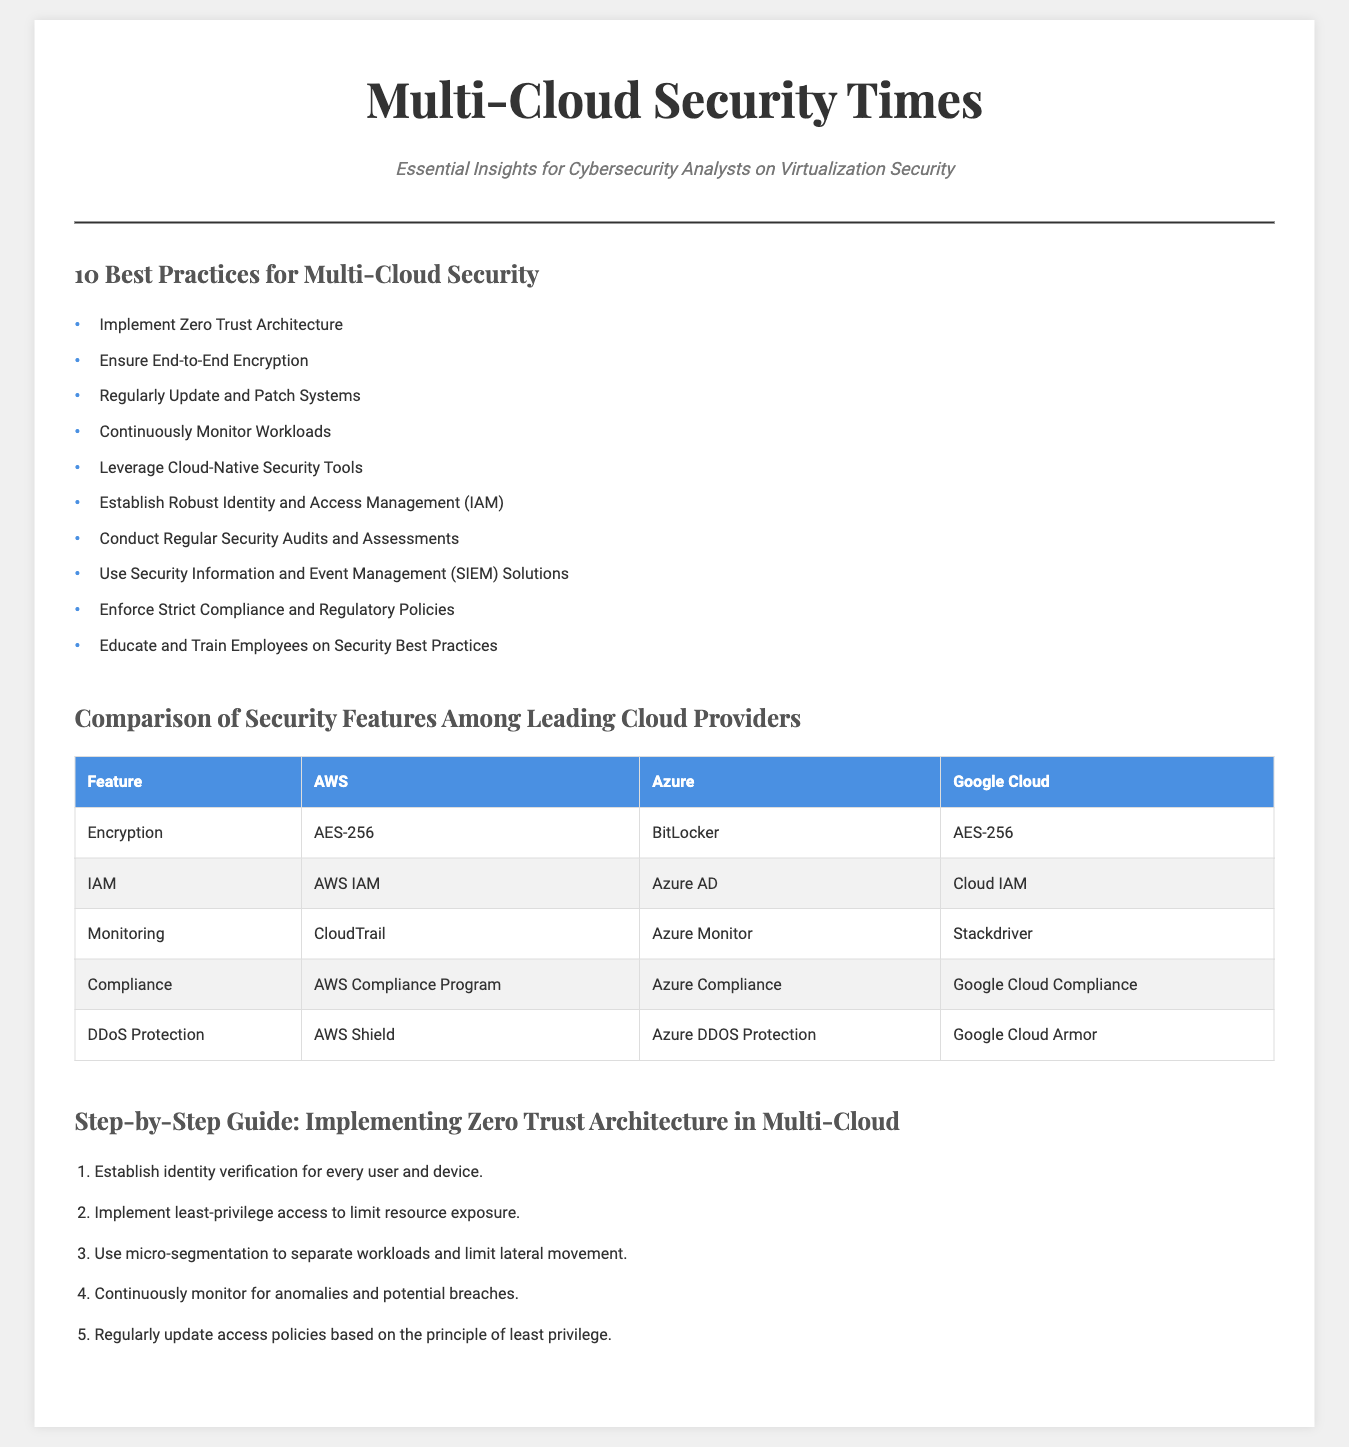What are the top practices for securing multi-cloud environments? The document lists ten best practices for multi-cloud security.
Answer: Implement Zero Trust Architecture, Ensure End-to-End Encryption, Regularly Update and Patch Systems, Continuously Monitor Workloads, Leverage Cloud-Native Security Tools, Establish Robust Identity and Access Management (IAM), Conduct Regular Security Audits and Assessments, Use Security Information and Event Management (SIEM) Solutions, Enforce Strict Compliance and Regulatory Policies, Educate and Train Employees on Security Best Practices Which encryption standard does AWS use? The document provides a comparison of security features among cloud providers, including encryption standards.
Answer: AES-256 What security feature is used by Azure for identity management? Identity management features are compared in the cloud providers' table.
Answer: Azure AD How many steps are specified in the guide for implementing Zero Trust Architecture? The guide section outlines a series of steps for Zero Trust Architecture.
Answer: 5 What is the primary purpose of the document? The overall theme of the document is examined to determine its intent.
Answer: Essential Insights for Cybersecurity Analysts on Virtualization Security Which cloud provider offers DDoS protection? The chart section lists various security features and the cloud providers that offer them.
Answer: AWS Shield, Azure DDOS Protection, Google Cloud Armor 